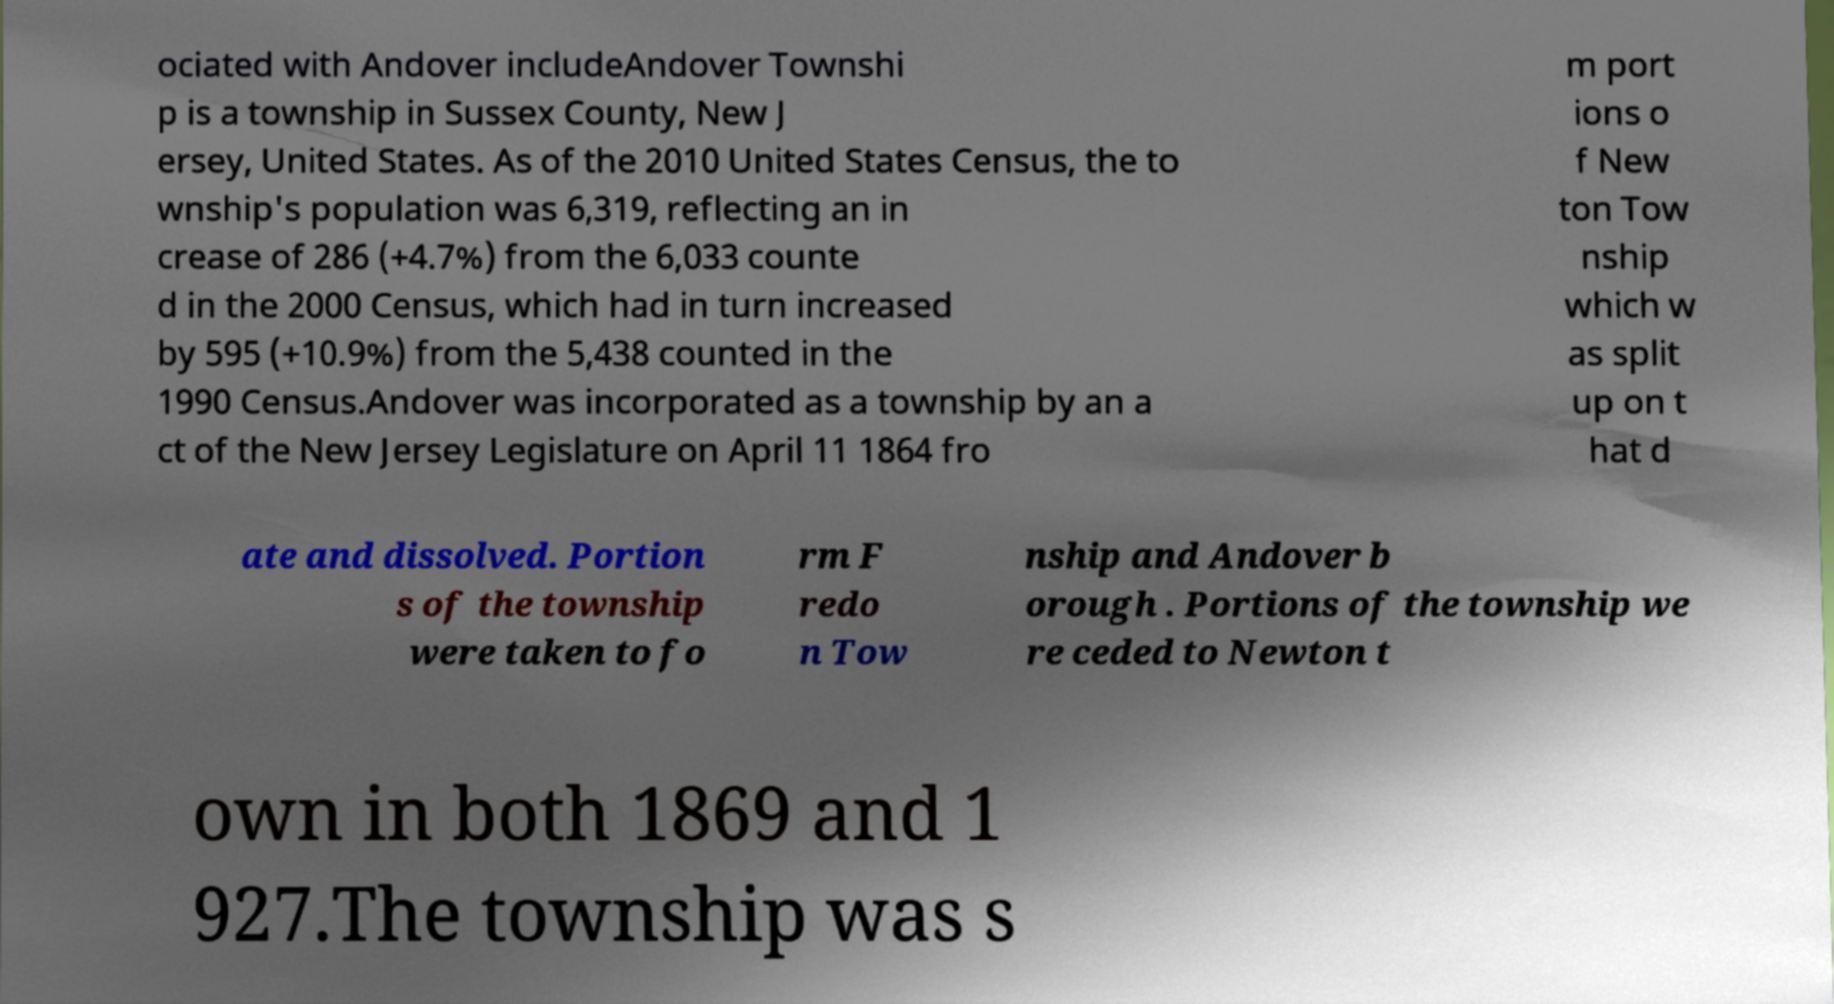Can you accurately transcribe the text from the provided image for me? ociated with Andover includeAndover Townshi p is a township in Sussex County, New J ersey, United States. As of the 2010 United States Census, the to wnship's population was 6,319, reflecting an in crease of 286 (+4.7%) from the 6,033 counte d in the 2000 Census, which had in turn increased by 595 (+10.9%) from the 5,438 counted in the 1990 Census.Andover was incorporated as a township by an a ct of the New Jersey Legislature on April 11 1864 fro m port ions o f New ton Tow nship which w as split up on t hat d ate and dissolved. Portion s of the township were taken to fo rm F redo n Tow nship and Andover b orough . Portions of the township we re ceded to Newton t own in both 1869 and 1 927.The township was s 